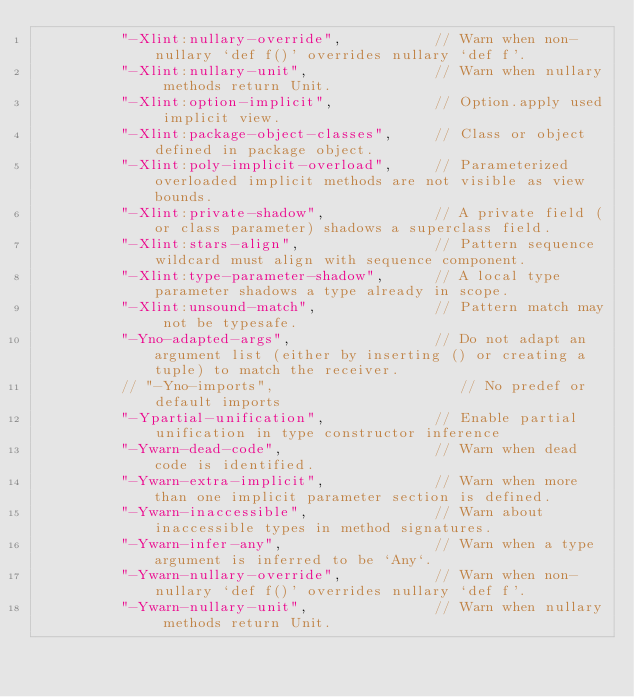Convert code to text. <code><loc_0><loc_0><loc_500><loc_500><_Scala_>          "-Xlint:nullary-override",           // Warn when non-nullary `def f()' overrides nullary `def f'.
          "-Xlint:nullary-unit",               // Warn when nullary methods return Unit.
          "-Xlint:option-implicit",            // Option.apply used implicit view.
          "-Xlint:package-object-classes",     // Class or object defined in package object.
          "-Xlint:poly-implicit-overload",     // Parameterized overloaded implicit methods are not visible as view bounds.
          "-Xlint:private-shadow",             // A private field (or class parameter) shadows a superclass field.
          "-Xlint:stars-align",                // Pattern sequence wildcard must align with sequence component.
          "-Xlint:type-parameter-shadow",      // A local type parameter shadows a type already in scope.
          "-Xlint:unsound-match",              // Pattern match may not be typesafe.
          "-Yno-adapted-args",                 // Do not adapt an argument list (either by inserting () or creating a tuple) to match the receiver.
          // "-Yno-imports",                      // No predef or default imports
          "-Ypartial-unification",             // Enable partial unification in type constructor inference
          "-Ywarn-dead-code",                  // Warn when dead code is identified.
          "-Ywarn-extra-implicit",             // Warn when more than one implicit parameter section is defined.
          "-Ywarn-inaccessible",               // Warn about inaccessible types in method signatures.
          "-Ywarn-infer-any",                  // Warn when a type argument is inferred to be `Any`.
          "-Ywarn-nullary-override",           // Warn when non-nullary `def f()' overrides nullary `def f'.
          "-Ywarn-nullary-unit",               // Warn when nullary methods return Unit.</code> 